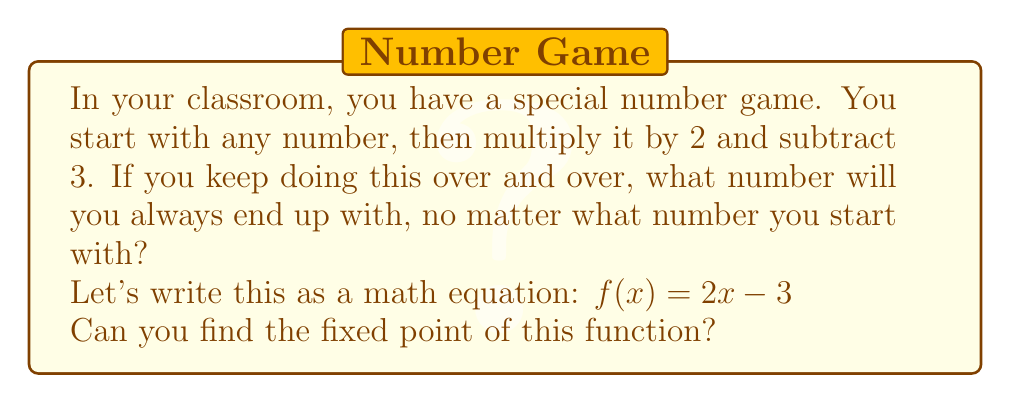Give your solution to this math problem. Let's approach this step-by-step:

1) A fixed point is a number that doesn't change when we apply the function. In mathematical terms, it's a value of $x$ where $f(x) = x$.

2) For our function $f(x) = 2x - 3$, we're looking for a value of $x$ where:

   $x = 2x - 3$

3) To solve this, let's subtract $x$ from both sides:

   $0 = x - 3$

4) Now, let's add 3 to both sides:

   $3 = x$

5) We can verify this by plugging 3 back into our original function:

   $f(3) = 2(3) - 3 = 6 - 3 = 3$

6) Indeed, when we input 3, we get 3 back out. This means 3 is the fixed point.

7) In the context of the classroom game, no matter what number the students start with, if they keep applying this rule (multiply by 2 and subtract 3), they will eventually converge to 3.

For example:
- Start with 0: 0 → -3 → -9 → -21 → -45 → -93 → ... → 3
- Start with 10: 10 → 17 → 31 → 59 → 115 → 227 → ... → 3

This concept introduces students to the idea of convergence in iterative functions, a fundamental concept in more advanced mathematics.
Answer: 3 